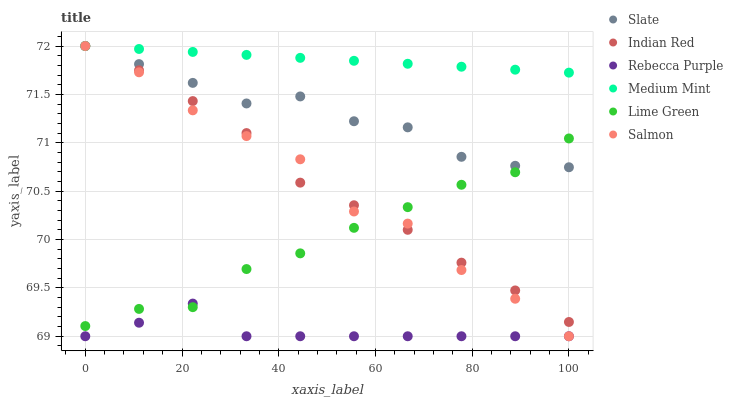Does Rebecca Purple have the minimum area under the curve?
Answer yes or no. Yes. Does Medium Mint have the maximum area under the curve?
Answer yes or no. Yes. Does Slate have the minimum area under the curve?
Answer yes or no. No. Does Slate have the maximum area under the curve?
Answer yes or no. No. Is Medium Mint the smoothest?
Answer yes or no. Yes. Is Salmon the roughest?
Answer yes or no. Yes. Is Slate the smoothest?
Answer yes or no. No. Is Slate the roughest?
Answer yes or no. No. Does Salmon have the lowest value?
Answer yes or no. Yes. Does Slate have the lowest value?
Answer yes or no. No. Does Indian Red have the highest value?
Answer yes or no. Yes. Does Rebecca Purple have the highest value?
Answer yes or no. No. Is Rebecca Purple less than Slate?
Answer yes or no. Yes. Is Medium Mint greater than Rebecca Purple?
Answer yes or no. Yes. Does Lime Green intersect Slate?
Answer yes or no. Yes. Is Lime Green less than Slate?
Answer yes or no. No. Is Lime Green greater than Slate?
Answer yes or no. No. Does Rebecca Purple intersect Slate?
Answer yes or no. No. 